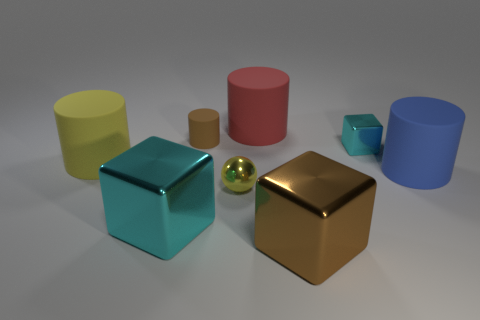Subtract all large cylinders. How many cylinders are left? 1 Add 2 small blue rubber things. How many objects exist? 10 Subtract all green cylinders. Subtract all purple blocks. How many cylinders are left? 4 Subtract all spheres. How many objects are left? 7 Subtract 0 purple cylinders. How many objects are left? 8 Subtract all purple metallic objects. Subtract all yellow rubber things. How many objects are left? 7 Add 6 big red cylinders. How many big red cylinders are left? 7 Add 3 small gray things. How many small gray things exist? 3 